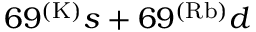<formula> <loc_0><loc_0><loc_500><loc_500>6 9 ^ { ( K ) } s + 6 9 ^ { ( R b ) } d</formula> 